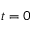<formula> <loc_0><loc_0><loc_500><loc_500>t = 0</formula> 